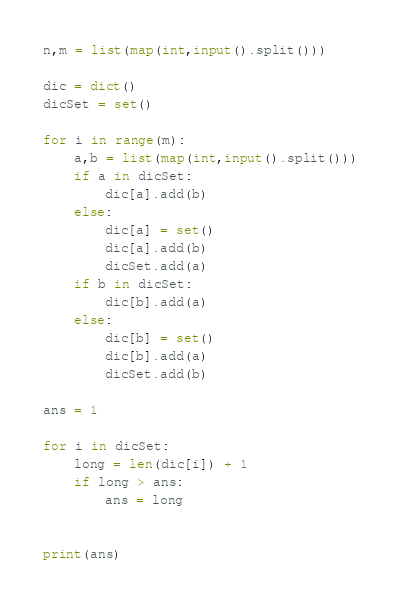<code> <loc_0><loc_0><loc_500><loc_500><_Python_>n,m = list(map(int,input().split()))

dic = dict()
dicSet = set()

for i in range(m):
    a,b = list(map(int,input().split()))
    if a in dicSet:
        dic[a].add(b)
    else:
        dic[a] = set()
        dic[a].add(b)
        dicSet.add(a)
    if b in dicSet:
        dic[b].add(a)
    else:
        dic[b] = set()
        dic[b].add(a)
        dicSet.add(b)

ans = 1

for i in dicSet:
    long = len(dic[i]) + 1
    if long > ans:
        ans = long


print(ans)</code> 